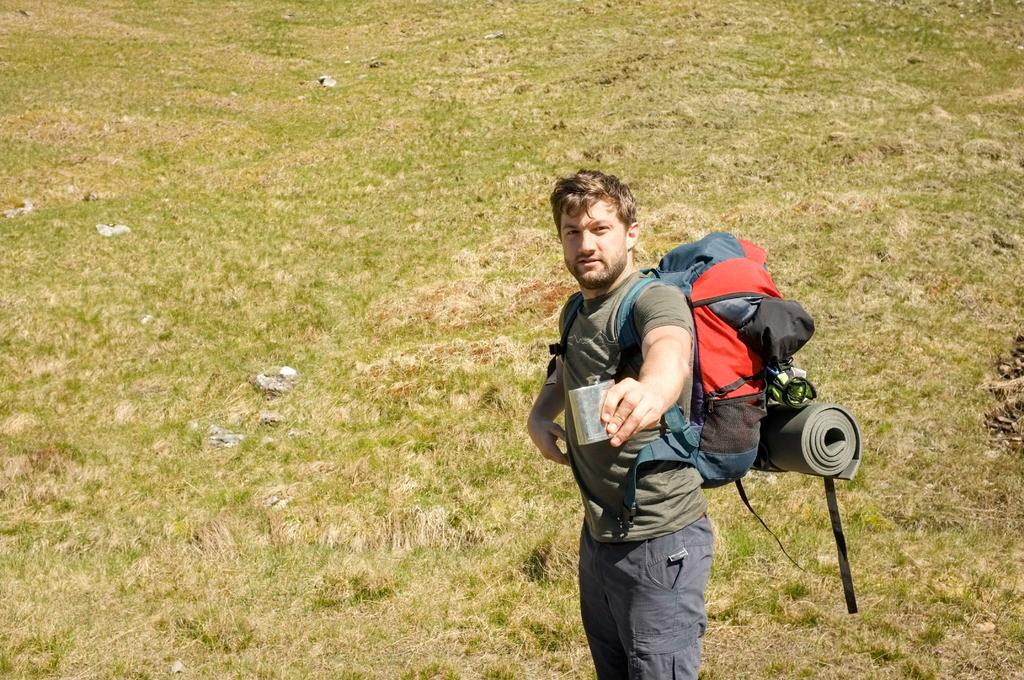What is the man in the image doing? The man is standing in the image. What is the man holding in his hand? The man is holding a whiskey bottle in his hand. What else is the man carrying in the image? The man is carrying a bag on his shoulders. What can be seen in the background of the image? There is land visible in the background of the image, and there is grass on the land. What type of sink can be seen in the image? There is no sink present in the image. What is the man eating for lunch in the image? The image does not show the man eating anything, so it cannot be determined what he might be having for lunch. 